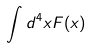<formula> <loc_0><loc_0><loc_500><loc_500>\int d ^ { 4 } x F ( x )</formula> 